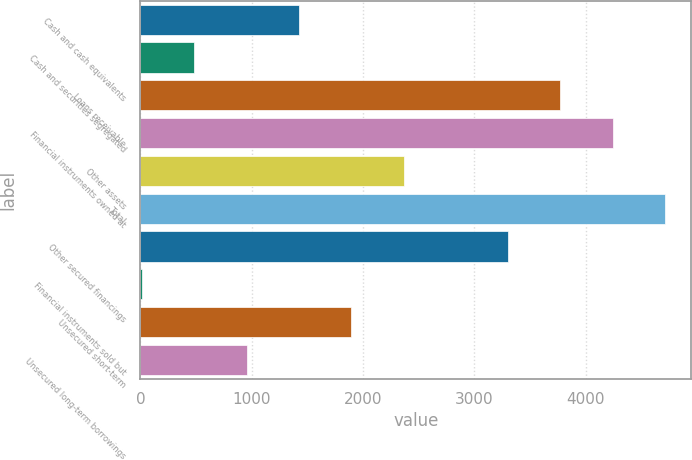Convert chart. <chart><loc_0><loc_0><loc_500><loc_500><bar_chart><fcel>Cash and cash equivalents<fcel>Cash and securities segregated<fcel>Loans receivable<fcel>Financial instruments owned at<fcel>Other assets<fcel>Total<fcel>Other secured financings<fcel>Financial instruments sold but<fcel>Unsecured short-term<fcel>Unsecured long-term borrowings<nl><fcel>1424.8<fcel>485.6<fcel>3772.8<fcel>4242.4<fcel>2364<fcel>4712<fcel>3303.2<fcel>16<fcel>1894.4<fcel>955.2<nl></chart> 